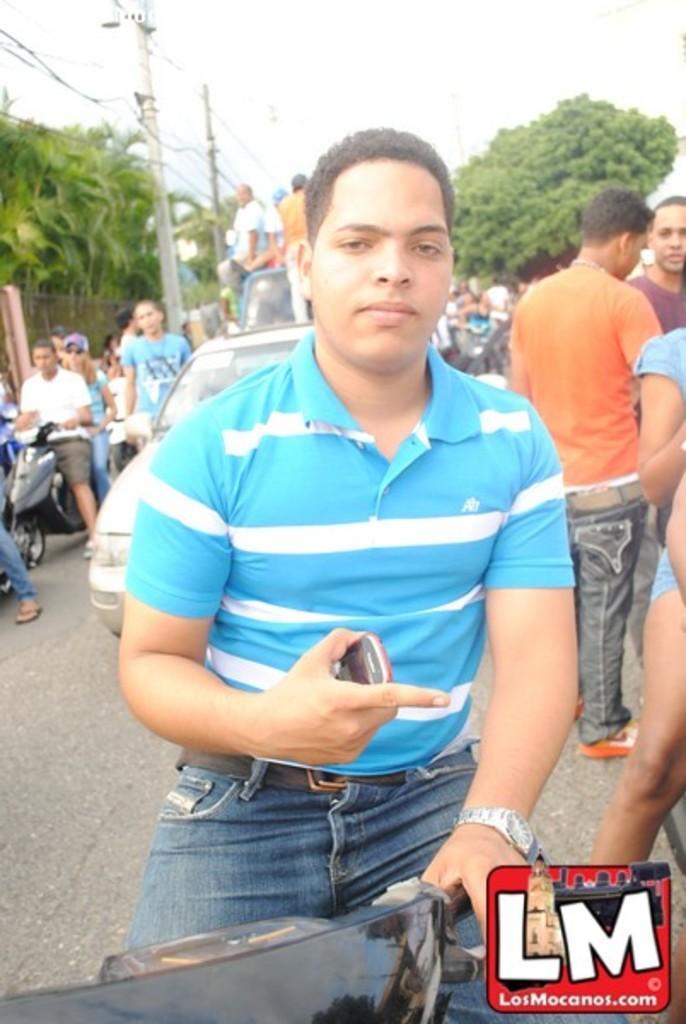Describe this image in one or two sentences. In this image I can see number of people and few of them are with their vehicles. Here I can see he is holding a phone and wearing a watch. In the background I can see few more vehicles and few people on it. Here I can see few trees and few polls. 